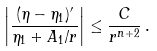Convert formula to latex. <formula><loc_0><loc_0><loc_500><loc_500>\left | \frac { ( \eta - \eta _ { 1 } ) ^ { \prime } } { \eta _ { 1 } + A _ { 1 } / r } \right | \leq \frac { C } { r ^ { n + 2 } } \, .</formula> 